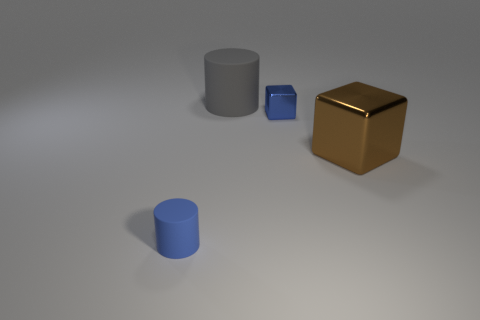There is a metal block that is in front of the tiny block; what is its color?
Offer a very short reply. Brown. Is there a big cylinder in front of the rubber object that is in front of the brown shiny object?
Keep it short and to the point. No. What number of other things are there of the same color as the large metal cube?
Provide a short and direct response. 0. Is the size of the rubber cylinder that is on the right side of the blue matte cylinder the same as the blue thing that is on the right side of the blue rubber object?
Your response must be concise. No. There is a block that is in front of the metallic block that is behind the big metallic cube; what size is it?
Ensure brevity in your answer.  Large. What material is the thing that is both in front of the tiny blue metal block and right of the gray rubber object?
Your response must be concise. Metal. What is the color of the tiny cylinder?
Offer a very short reply. Blue. Are there any other things that have the same material as the blue block?
Your response must be concise. Yes. There is a small thing that is behind the blue matte thing; what shape is it?
Make the answer very short. Cube. Are there any matte objects right of the large thing behind the big object in front of the gray object?
Give a very brief answer. No. 